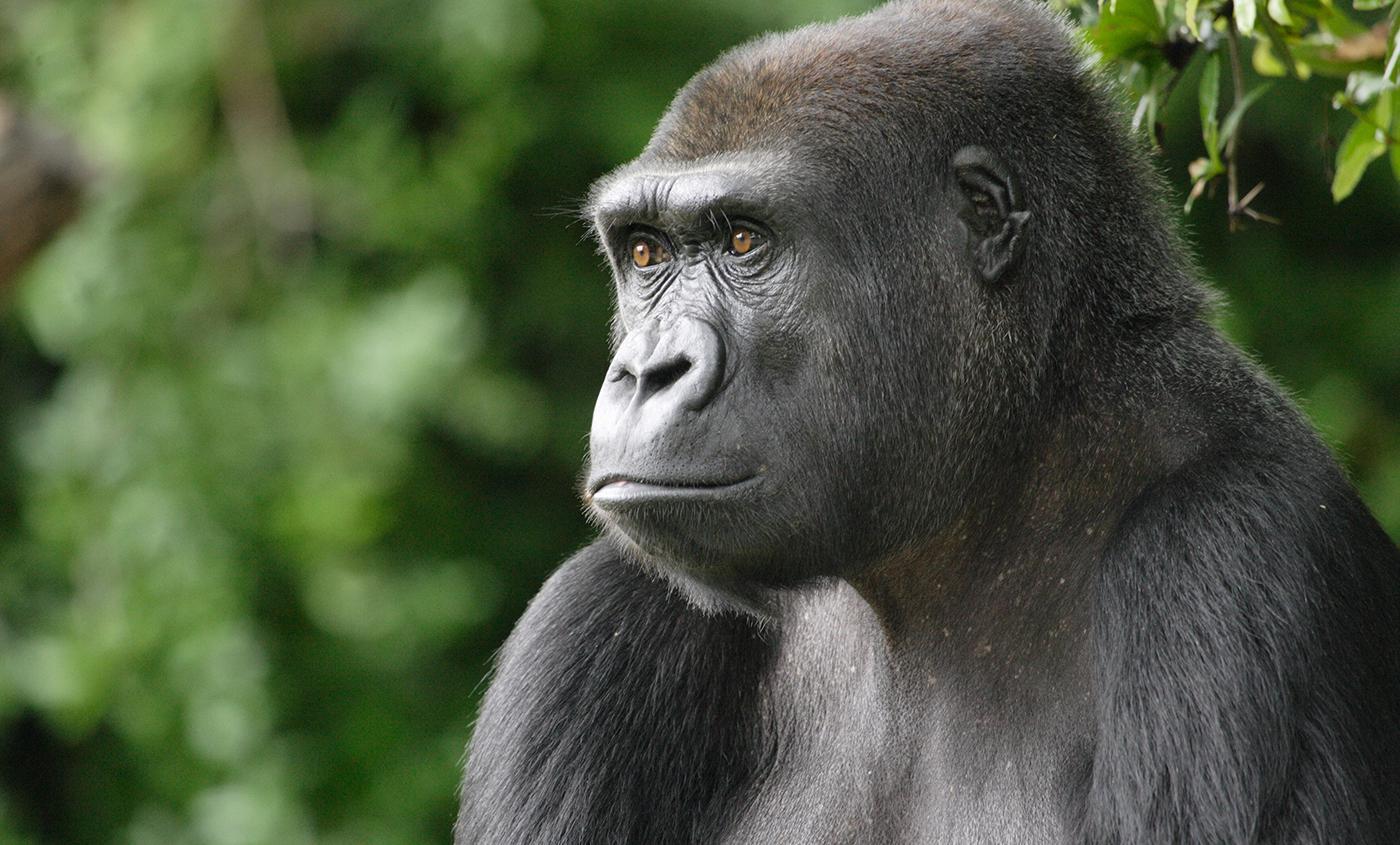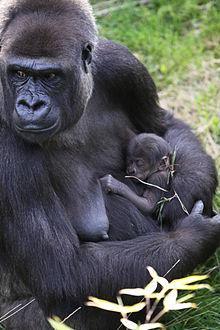The first image is the image on the left, the second image is the image on the right. For the images shown, is this caption "The nipples are hanging down on an adult primate in the image on the right." true? Answer yes or no. Yes. The first image is the image on the left, the second image is the image on the right. Examine the images to the left and right. Is the description "A baby gorilla is holding onto an adult in an image with only two gorillas." accurate? Answer yes or no. Yes. 